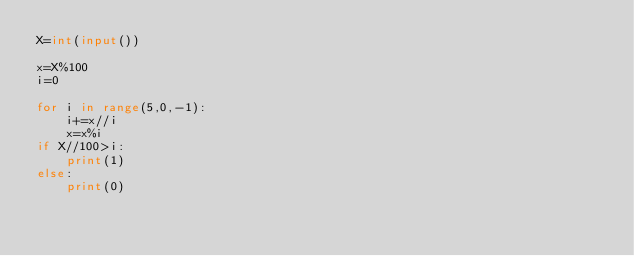Convert code to text. <code><loc_0><loc_0><loc_500><loc_500><_Python_>X=int(input())

x=X%100
i=0

for i in range(5,0,-1):
    i+=x//i
    x=x%i
if X//100>i:
    print(1)
else:
    print(0)</code> 